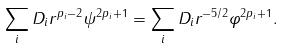<formula> <loc_0><loc_0><loc_500><loc_500>\sum _ { i } D _ { i } r ^ { p _ { i } - 2 } \psi ^ { 2 p _ { i } + 1 } = \sum _ { i } D _ { i } r ^ { - 5 / 2 } \varphi ^ { 2 p _ { i } + 1 } .</formula> 